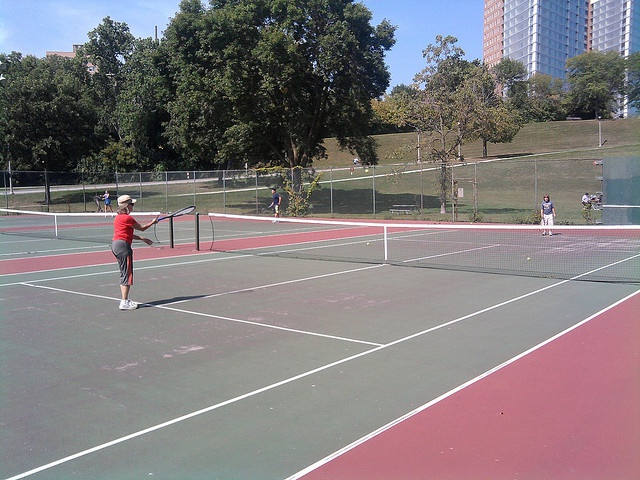Describe the objects in this image and their specific colors. I can see people in lightblue, maroon, gray, black, and darkgray tones, people in lightblue, lavender, darkgray, and gray tones, people in lightblue, gray, black, navy, and lightpink tones, tennis racket in lightblue, darkgray, gray, black, and lightgray tones, and people in lightblue, gray, navy, and black tones in this image. 